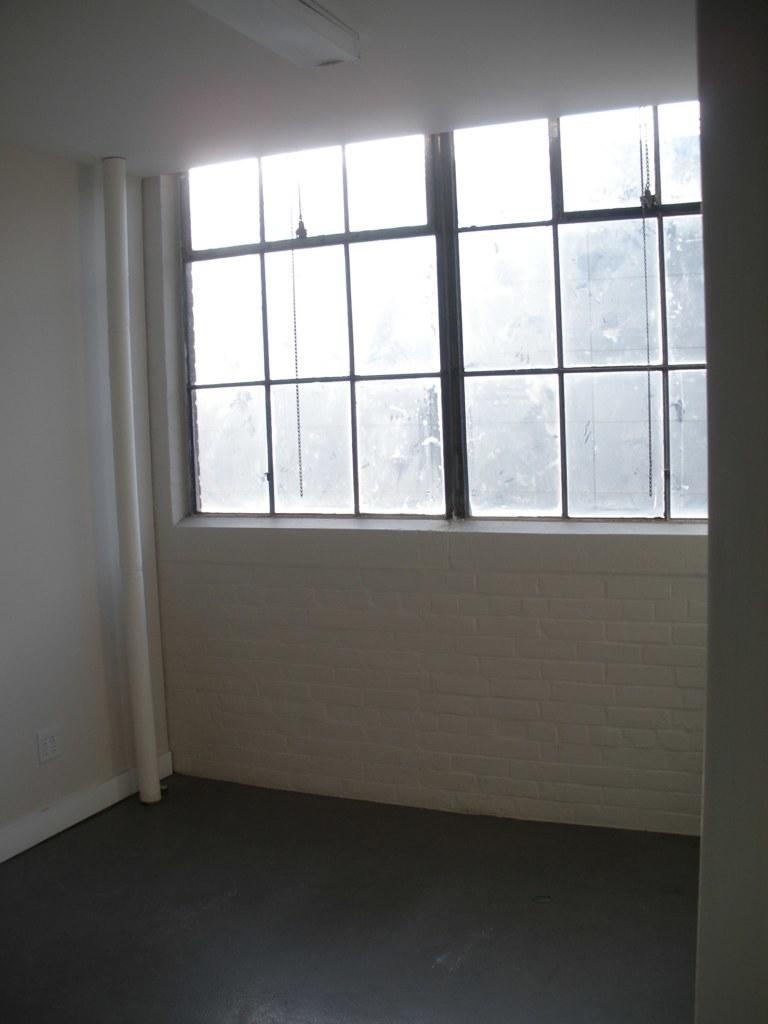What type of space is depicted in the image? The image shows the interior of a room. What can be found under the people's feet in the room? There is a floor in the room. What color are the walls in the room? The walls in the room are white-colored. What is the purpose of the pipe in the room? The purpose of the pipe in the room is not specified in the image. What is above the people's heads in the room? There is a ceiling in the room. What is attached to the ceiling in the room? A light is attached to the ceiling. What feature allows natural light to enter the room? There is a window in the room. What type of glass can be seen floating in the room? There is no glass floating in the room; the image only shows the interior of a room with a floor, white-colored walls, a pipe, a ceiling, a light, and a window. 